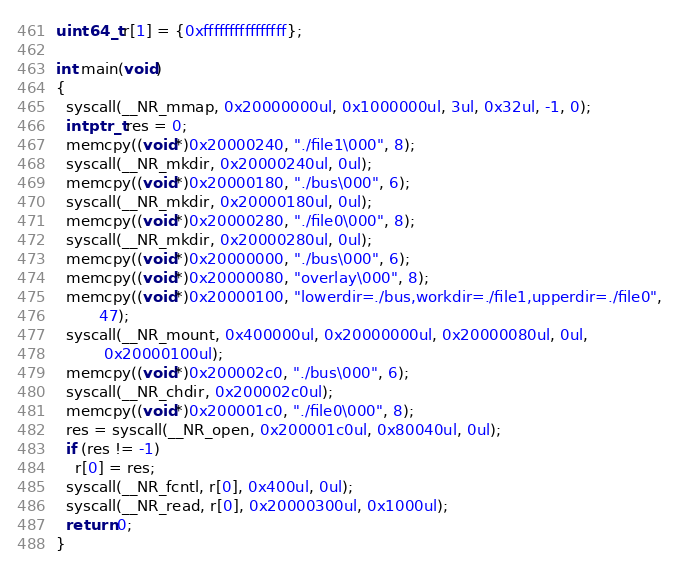<code> <loc_0><loc_0><loc_500><loc_500><_C_>
uint64_t r[1] = {0xffffffffffffffff};

int main(void)
{
  syscall(__NR_mmap, 0x20000000ul, 0x1000000ul, 3ul, 0x32ul, -1, 0);
  intptr_t res = 0;
  memcpy((void*)0x20000240, "./file1\000", 8);
  syscall(__NR_mkdir, 0x20000240ul, 0ul);
  memcpy((void*)0x20000180, "./bus\000", 6);
  syscall(__NR_mkdir, 0x20000180ul, 0ul);
  memcpy((void*)0x20000280, "./file0\000", 8);
  syscall(__NR_mkdir, 0x20000280ul, 0ul);
  memcpy((void*)0x20000000, "./bus\000", 6);
  memcpy((void*)0x20000080, "overlay\000", 8);
  memcpy((void*)0x20000100, "lowerdir=./bus,workdir=./file1,upperdir=./file0",
         47);
  syscall(__NR_mount, 0x400000ul, 0x20000000ul, 0x20000080ul, 0ul,
          0x20000100ul);
  memcpy((void*)0x200002c0, "./bus\000", 6);
  syscall(__NR_chdir, 0x200002c0ul);
  memcpy((void*)0x200001c0, "./file0\000", 8);
  res = syscall(__NR_open, 0x200001c0ul, 0x80040ul, 0ul);
  if (res != -1)
    r[0] = res;
  syscall(__NR_fcntl, r[0], 0x400ul, 0ul);
  syscall(__NR_read, r[0], 0x20000300ul, 0x1000ul);
  return 0;
}
</code> 